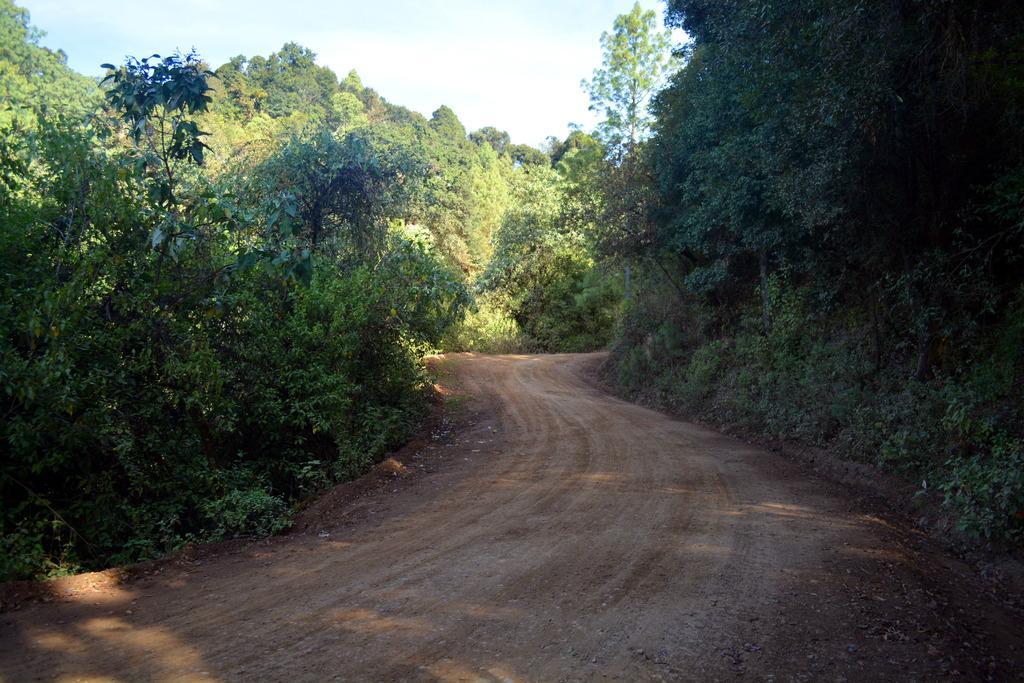Please provide a concise description of this image. In this image we can see the trees and also the path. We can also see the sky. 